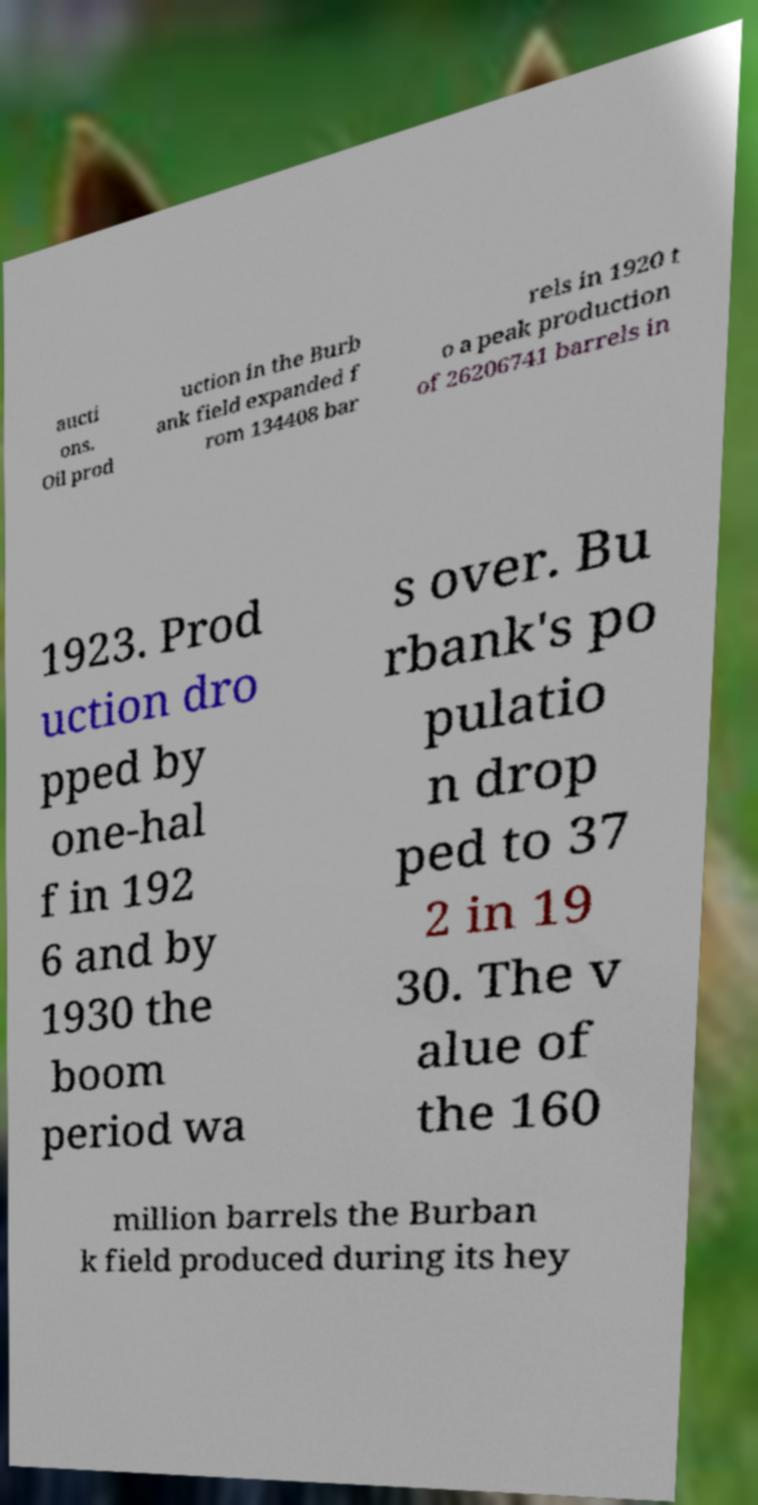Can you read and provide the text displayed in the image?This photo seems to have some interesting text. Can you extract and type it out for me? aucti ons. Oil prod uction in the Burb ank field expanded f rom 134408 bar rels in 1920 t o a peak production of 26206741 barrels in 1923. Prod uction dro pped by one-hal f in 192 6 and by 1930 the boom period wa s over. Bu rbank's po pulatio n drop ped to 37 2 in 19 30. The v alue of the 160 million barrels the Burban k field produced during its hey 